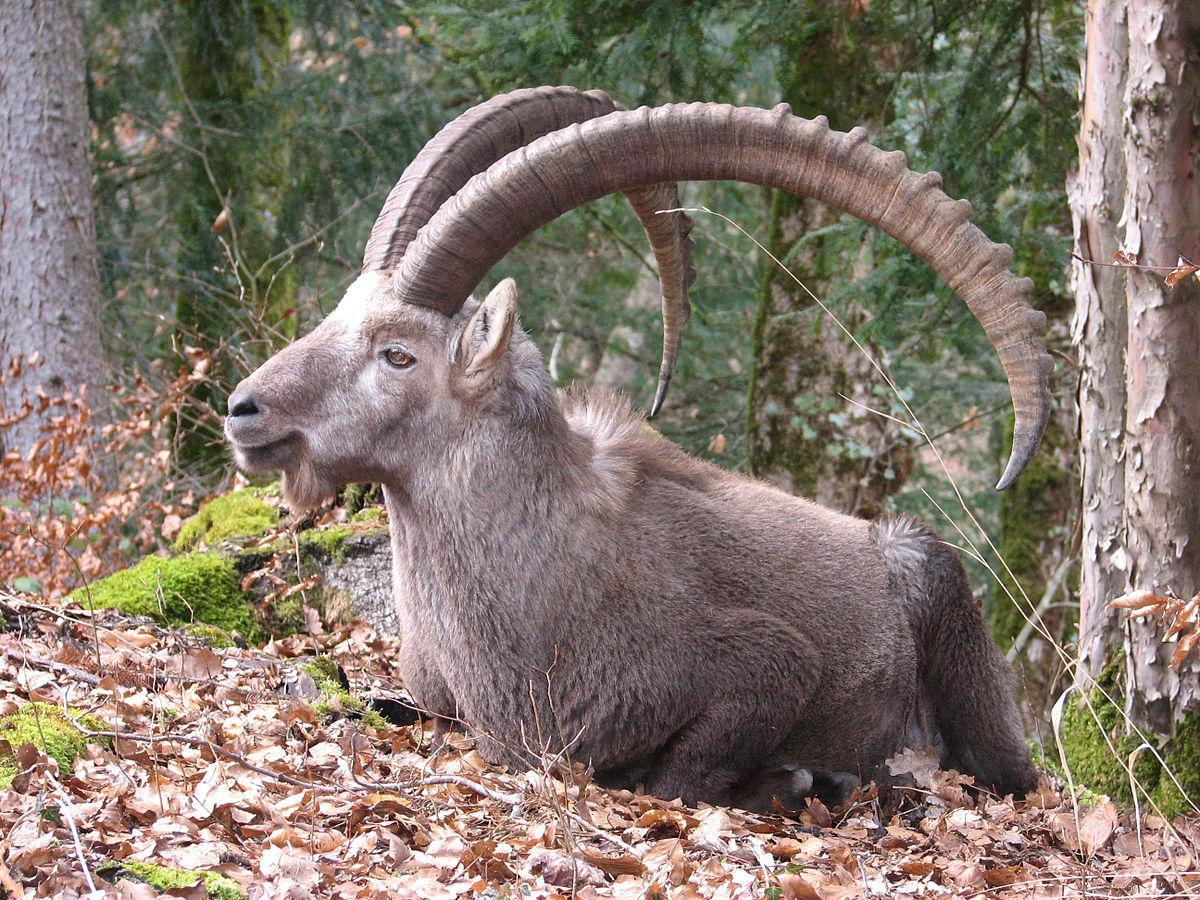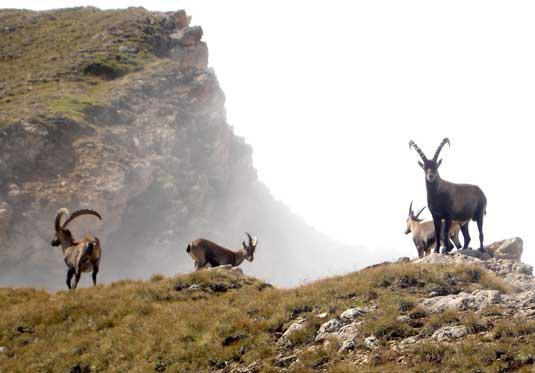The first image is the image on the left, the second image is the image on the right. Assess this claim about the two images: "One of the images contains a single animal.". Correct or not? Answer yes or no. Yes. The first image is the image on the left, the second image is the image on the right. Evaluate the accuracy of this statement regarding the images: "the image on the lft contains a single antelope". Is it true? Answer yes or no. Yes. 